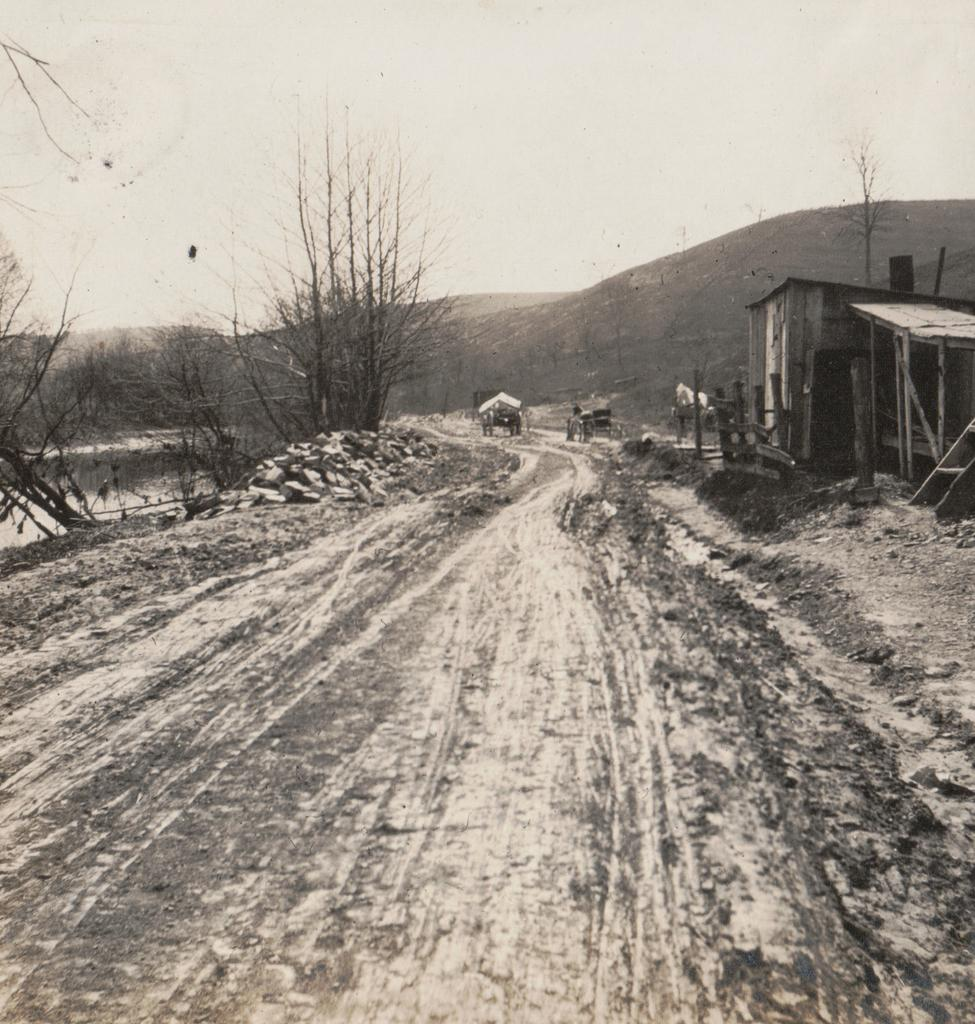What type of surface can be seen in the image? There is a path in the image. What material is present on the path? Stones are present in the image. What type of vegetation is visible in the image? There are trees in the image. What geographical feature can be seen in the distance? Mountains are visible in the image. What part of the natural environment is visible in the image? The sky is visible in the image. What body of water is present in the image? There is water visible in the image. What mode of transportation is present in the image? A cart is present in the image. What type of building is visible in the image? There is a wooden house in the image. What type of air is blowing through the trees in the image? There is no mention of air blowing through the trees in the image. How does the wooden house cry in the image? The wooden house does not cry in the image; it is an inanimate object. 